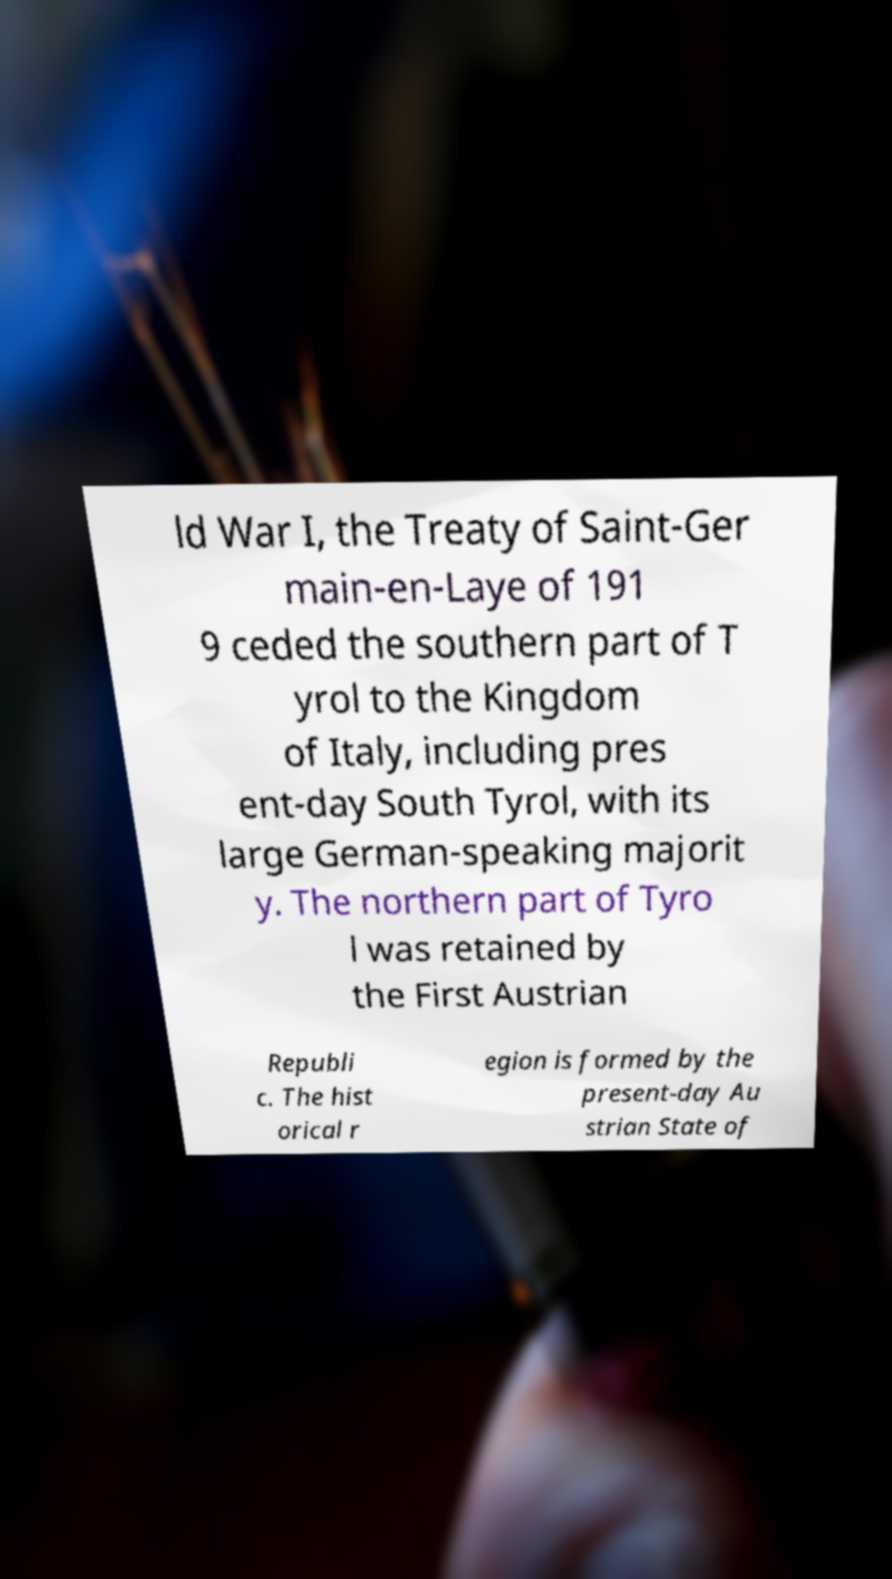Could you extract and type out the text from this image? ld War I, the Treaty of Saint-Ger main-en-Laye of 191 9 ceded the southern part of T yrol to the Kingdom of Italy, including pres ent-day South Tyrol, with its large German-speaking majorit y. The northern part of Tyro l was retained by the First Austrian Republi c. The hist orical r egion is formed by the present-day Au strian State of 